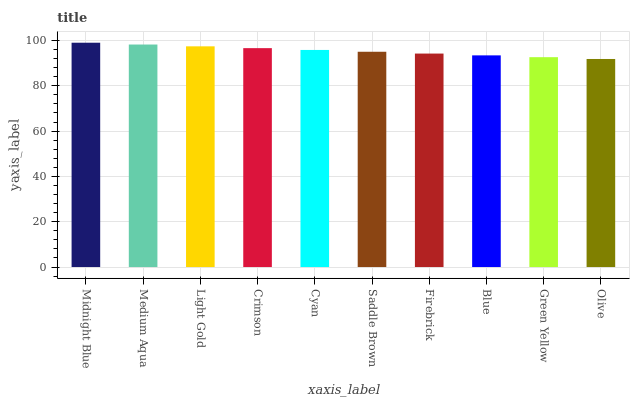Is Olive the minimum?
Answer yes or no. Yes. Is Midnight Blue the maximum?
Answer yes or no. Yes. Is Medium Aqua the minimum?
Answer yes or no. No. Is Medium Aqua the maximum?
Answer yes or no. No. Is Midnight Blue greater than Medium Aqua?
Answer yes or no. Yes. Is Medium Aqua less than Midnight Blue?
Answer yes or no. Yes. Is Medium Aqua greater than Midnight Blue?
Answer yes or no. No. Is Midnight Blue less than Medium Aqua?
Answer yes or no. No. Is Cyan the high median?
Answer yes or no. Yes. Is Saddle Brown the low median?
Answer yes or no. Yes. Is Blue the high median?
Answer yes or no. No. Is Blue the low median?
Answer yes or no. No. 